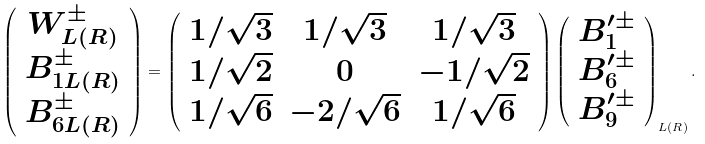<formula> <loc_0><loc_0><loc_500><loc_500>\left ( \begin{array} { c } W ^ { \pm } _ { L ( R ) } \\ B ^ { \pm } _ { 1 L ( R ) } \\ B ^ { \pm } _ { 6 L ( R ) } \end{array} \right ) = \left ( \begin{array} { c c c } 1 / \sqrt { 3 } & 1 / \sqrt { 3 } & 1 / \sqrt { 3 } \\ 1 / \sqrt { 2 } & 0 & - 1 / \sqrt { 2 } \\ 1 / \sqrt { 6 } & - 2 / \sqrt { 6 } & 1 / \sqrt { 6 } \end{array} \right ) \left ( \begin{array} { c } B ^ { \prime \pm } _ { 1 } \\ B ^ { \prime \pm } _ { 6 } \\ B ^ { \prime \pm } _ { 9 } \end{array} \right ) _ { L ( R ) } .</formula> 